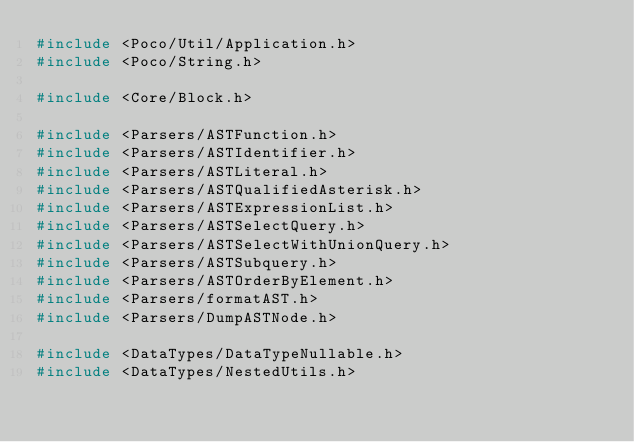Convert code to text. <code><loc_0><loc_0><loc_500><loc_500><_C++_>#include <Poco/Util/Application.h>
#include <Poco/String.h>

#include <Core/Block.h>

#include <Parsers/ASTFunction.h>
#include <Parsers/ASTIdentifier.h>
#include <Parsers/ASTLiteral.h>
#include <Parsers/ASTQualifiedAsterisk.h>
#include <Parsers/ASTExpressionList.h>
#include <Parsers/ASTSelectQuery.h>
#include <Parsers/ASTSelectWithUnionQuery.h>
#include <Parsers/ASTSubquery.h>
#include <Parsers/ASTOrderByElement.h>
#include <Parsers/formatAST.h>
#include <Parsers/DumpASTNode.h>

#include <DataTypes/DataTypeNullable.h>
#include <DataTypes/NestedUtils.h></code> 